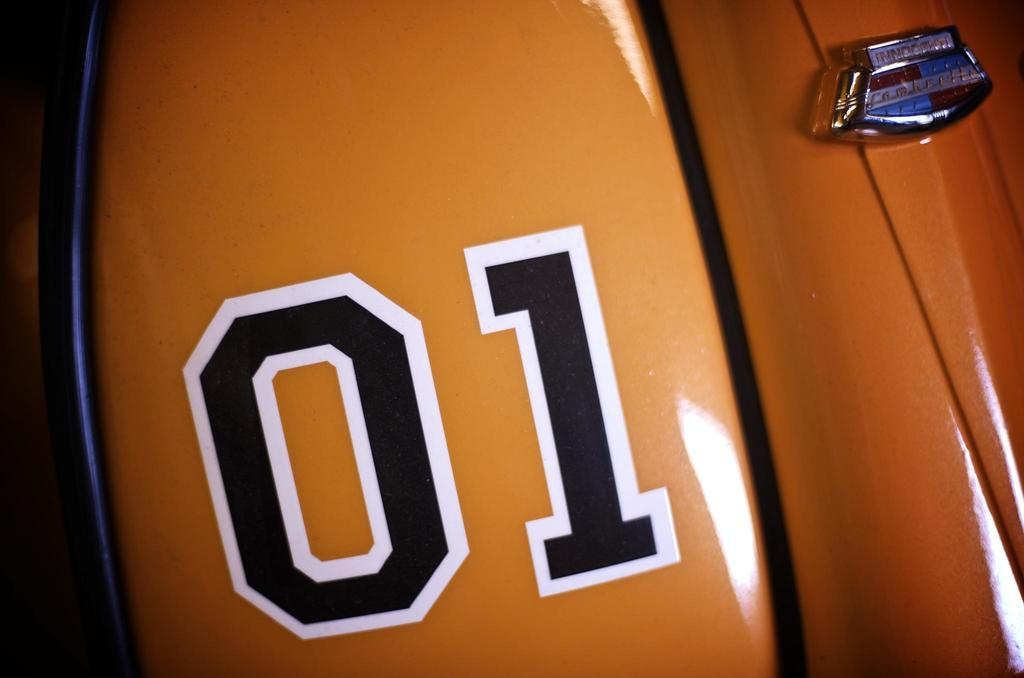What is the main subject of the image? There is a vehicle in the image. What colors can be seen on the vehicle? The vehicle has brown and black colors. Can you describe the background of the image? The background of the image is blurred. What type of rhythm can be heard coming from the vehicle in the image? There is no sound or rhythm present in the image, as it only features a vehicle with brown and black colors and a blurred background. 